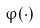Convert formula to latex. <formula><loc_0><loc_0><loc_500><loc_500>\varphi ( \cdot )</formula> 